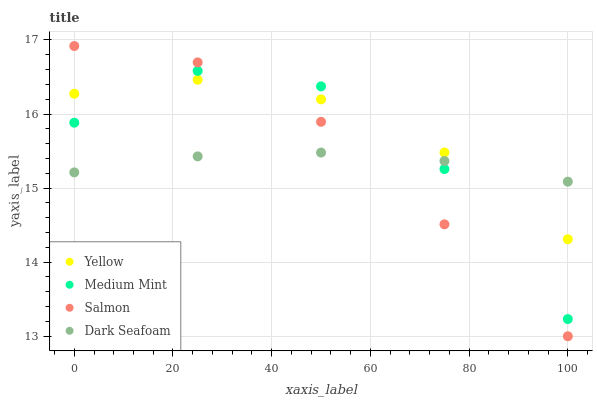Does Dark Seafoam have the minimum area under the curve?
Answer yes or no. Yes. Does Yellow have the maximum area under the curve?
Answer yes or no. Yes. Does Salmon have the minimum area under the curve?
Answer yes or no. No. Does Salmon have the maximum area under the curve?
Answer yes or no. No. Is Dark Seafoam the smoothest?
Answer yes or no. Yes. Is Medium Mint the roughest?
Answer yes or no. Yes. Is Salmon the smoothest?
Answer yes or no. No. Is Salmon the roughest?
Answer yes or no. No. Does Salmon have the lowest value?
Answer yes or no. Yes. Does Dark Seafoam have the lowest value?
Answer yes or no. No. Does Salmon have the highest value?
Answer yes or no. Yes. Does Dark Seafoam have the highest value?
Answer yes or no. No. Does Yellow intersect Medium Mint?
Answer yes or no. Yes. Is Yellow less than Medium Mint?
Answer yes or no. No. Is Yellow greater than Medium Mint?
Answer yes or no. No. 